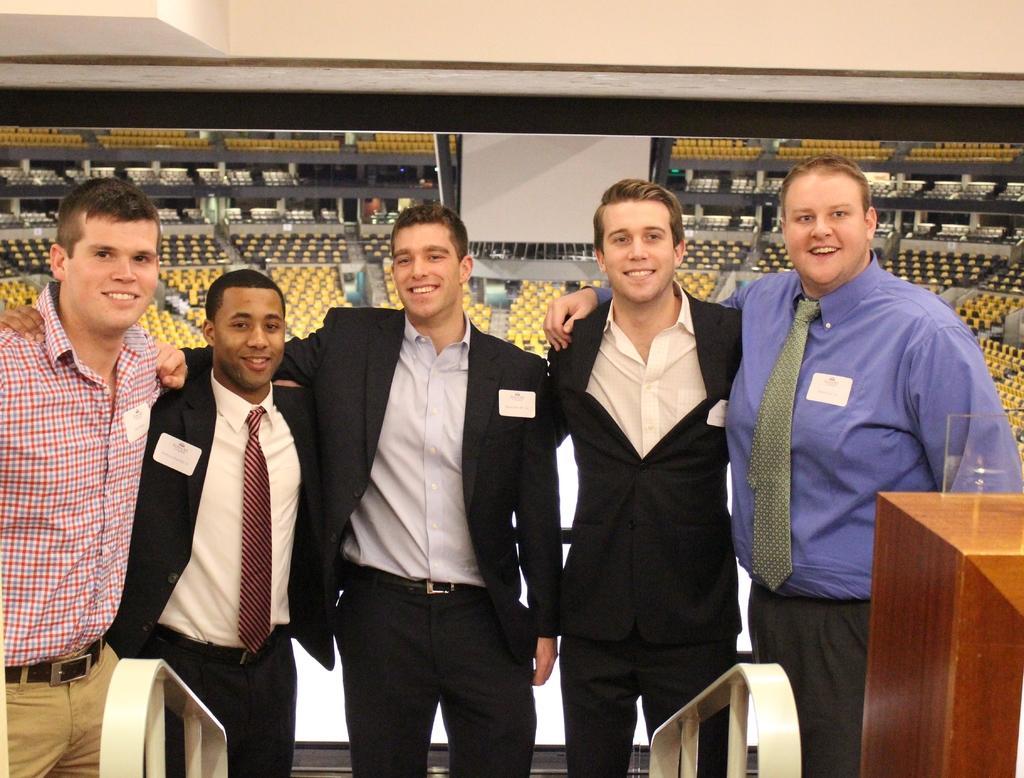Can you describe this image briefly? This picture looks like a stadium, there are some people standing and smiling, also we can see a wooden object which looks like a table, in the background we can see some chairs, poles and a poster. 